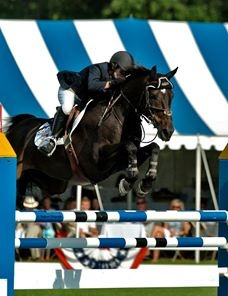Describe the objects in this image and their specific colors. I can see horse in black and gray tones, people in black, gray, white, and blue tones, people in black, darkgray, gray, and ivory tones, people in black, gray, and maroon tones, and people in black, gray, darkgray, and tan tones in this image. 